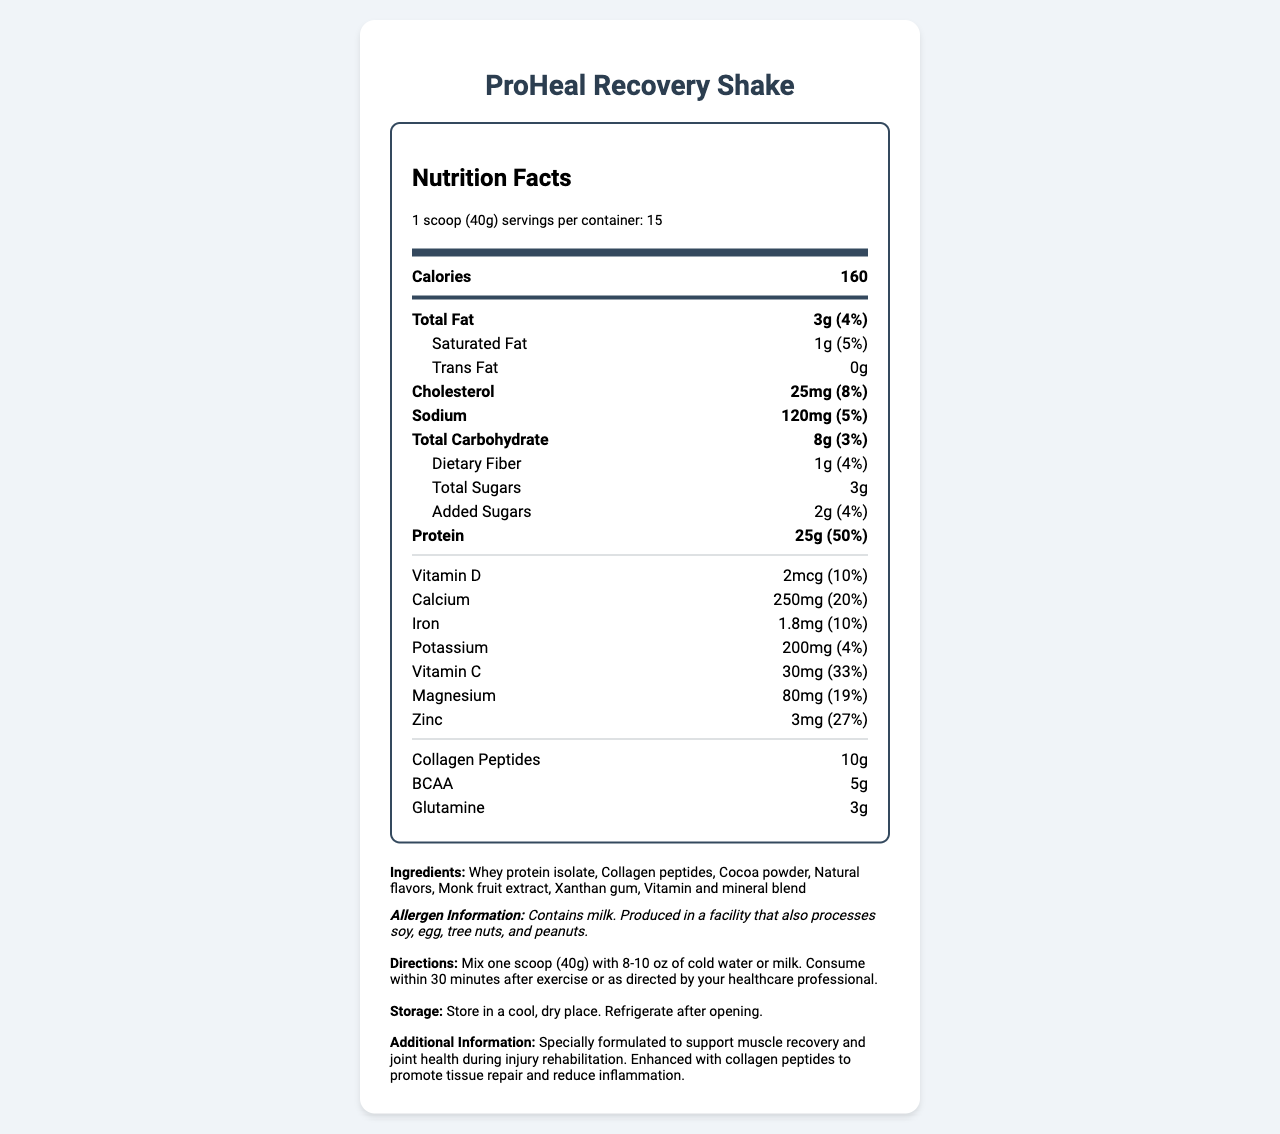what is the serving size for the ProHeal Recovery Shake? The serving size is clearly stated in the document as "1 scoop (40g)".
Answer: 1 scoop (40g) how many calories are in one serving of the ProHeal Recovery Shake? The document specifies that each serving contains 160 calories.
Answer: 160 how much protein does one serving of the ProHeal Recovery Shake contain? According to the document, one serving contains 25g of protein.
Answer: 25g what is the daily value percentage of calcium in a serving? The document indicates that the daily value percentage for calcium in one serving is 20%.
Answer: 20% how many grams of total carbohydrates are there in each serving? The document states that there are 8g of total carbohydrates in each serving.
Answer: 8g how much collagen peptides are in one serving? The document lists 10g of collagen peptides per serving.
Answer: 10g what allergens should be noted in the ProHeal Recovery Shake? A. Contains soy B. Contains milk C. Contains gluten D. Contains fish The allergen information specifies that the product contains milk and is produced in a facility that also processes soy, egg, tree nuts, and peanuts.
Answer: B which of the following ingredients is NOT listed in the ProHeal Recovery Shake? A. Collagen peptides B. Cocoa powder C. Aspartame D. Monk fruit extract The listed ingredients do not include aspartame; the correct answer is C.
Answer: C should the ProHeal Recovery Shake be refrigerated after opening? The document states that the product should be stored in a cool, dry place and refrigerated after opening.
Answer: Yes does the ProHeal Recovery Shake contain any dietary fiber? The document mentions that each serving contains 1g of dietary fiber.
Answer: Yes summarize the key nutritional benefits of the ProHeal Recovery Shake. The summary is derived from the product's emphasis on high protein for muscle recovery, collagen peptides for joint health, and various vitamins and minerals supporting overall health, all highlighted in the document.
Answer: The ProHeal Recovery Shake focuses on muscle recovery and joint health with high protein content (25g) and added collagen peptides (10g). It also includes essential vitamins and minerals such as calcium, vitamin D, vitamin C, magnesium, and zinc, which help support overall recovery and reduce inflammation. what is the exact amount of vitamin C in one serving of the shake? The document specifies that one serving includes 30mg of vitamin C.
Answer: 30mg how many servings are there per container of the ProHeal Recovery Shake? The document states that each container provides 15 servings.
Answer: 15 is the ProHeal Recovery Shake suitable for people with peanut allergies? The document states it is produced in a facility that processes peanuts, but it does not explicitly confirm whether the product itself is peanut-free.
Answer: Cannot be determined what specific benefit do the collagen peptides in the shake provide? The additional information section specifies that collagen peptides promote tissue repair and reduce inflammation, particularly beneficial during injury rehabilitation.
Answer: Promote tissue repair and reduce inflammation 